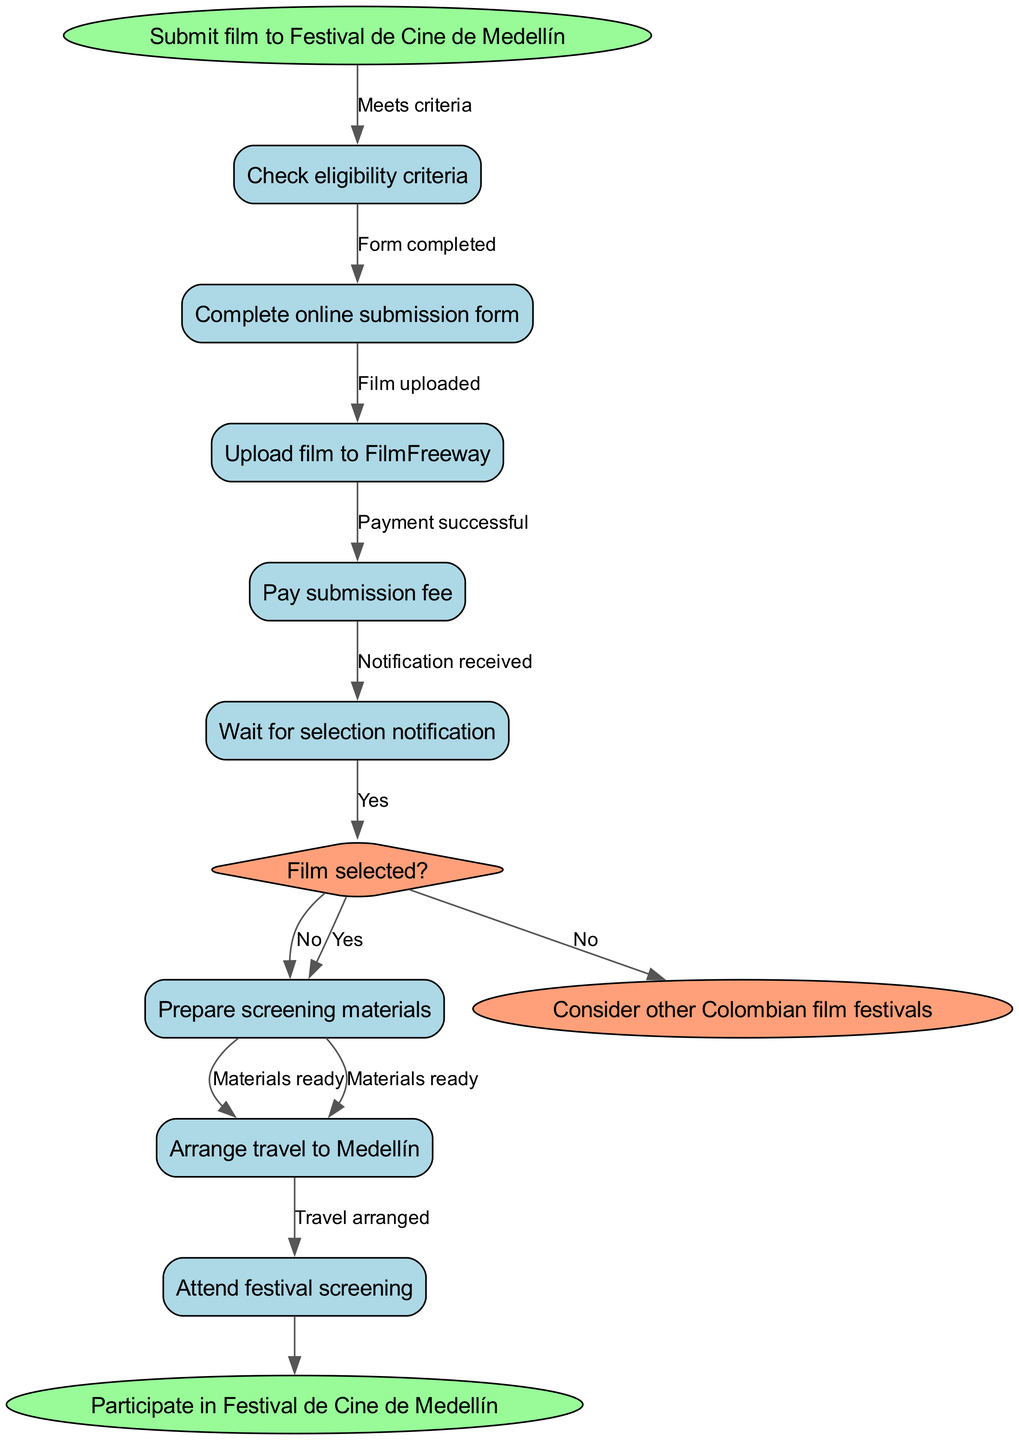What is the first step in the submission process? The flowchart indicates that the first step is to "Submit film to Festival de Cine de Medellín," which is the starting action in the process.
Answer: Submit film to Festival de Cine de Medellín How many nodes are there in the flowchart? Counting all nodes listed, there are a total of 9 nodes present in the diagram, including starting and ending nodes.
Answer: 9 What represents a decision point in the flowchart? The diamond-shaped node "Film selected?" represents a decision point, which indicates a check between two outcomes (yes/no).
Answer: Film selected? What do you do if the film is not selected? The flowchart directs users to "Consider other Colombian film festivals" if the film is not selected, indicating the subsequent action for that scenario.
Answer: Consider other Colombian film festivals How many edges point to the success end node? There is one edge leading to the success end node, coming from the last processing step "Attend festival screening."
Answer: 1 Which node follows after "Pay submission fee"? The next node after "Pay submission fee" is "Wait for selection notification," as depicted in the flow of the diagram/steps after payment completion.
Answer: Wait for selection notification What happens after "Film selected?" if the answer is yes? If the answer to "Film selected?" is yes, the next node in the flowchart is "Prepare screening materials," indicating the next step in case of selection.
Answer: Prepare screening materials What occurs after the "Attend festival screening" node? Following the "Attend festival screening" node, the process culminates in the success endpoint, leading to participation in the festival.
Answer: Participate in Festival de Cine de Medellín What is the last node in case of failure? The last node in case of failure is "Consider other Colombian film festivals," which outlines what to do if the film submission is unsuccessful.
Answer: Consider other Colombian film festivals 